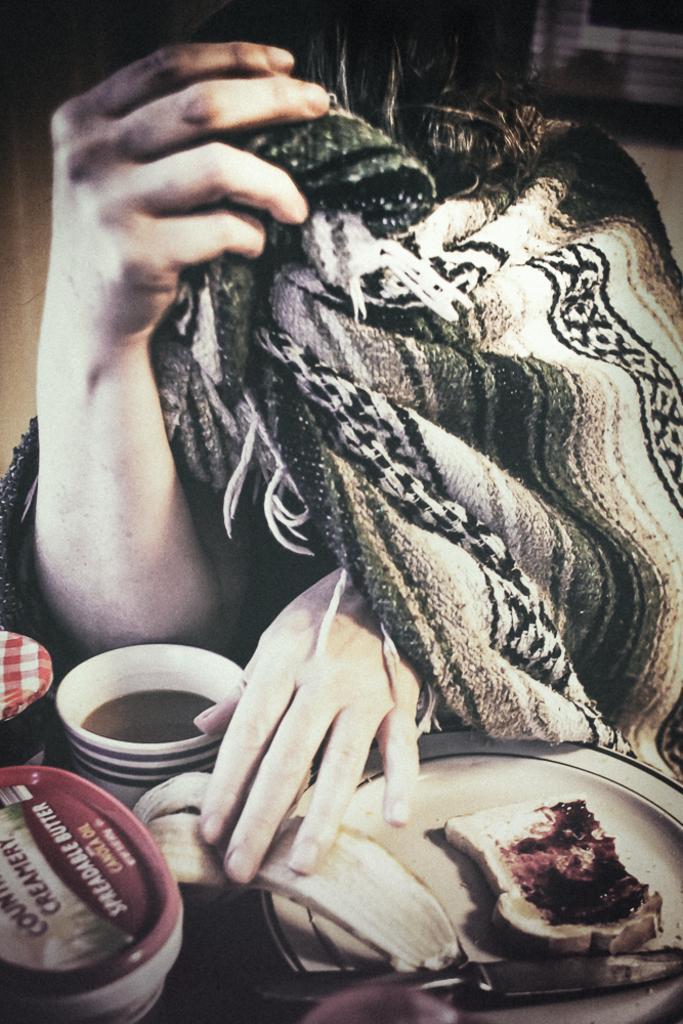How would you summarize this image in a sentence or two? In the image there is person with a blanket wrapped around keeping hand on banana peel which is on plate with bread,jam,knife on a table along with a coffee cup and few bottles. 